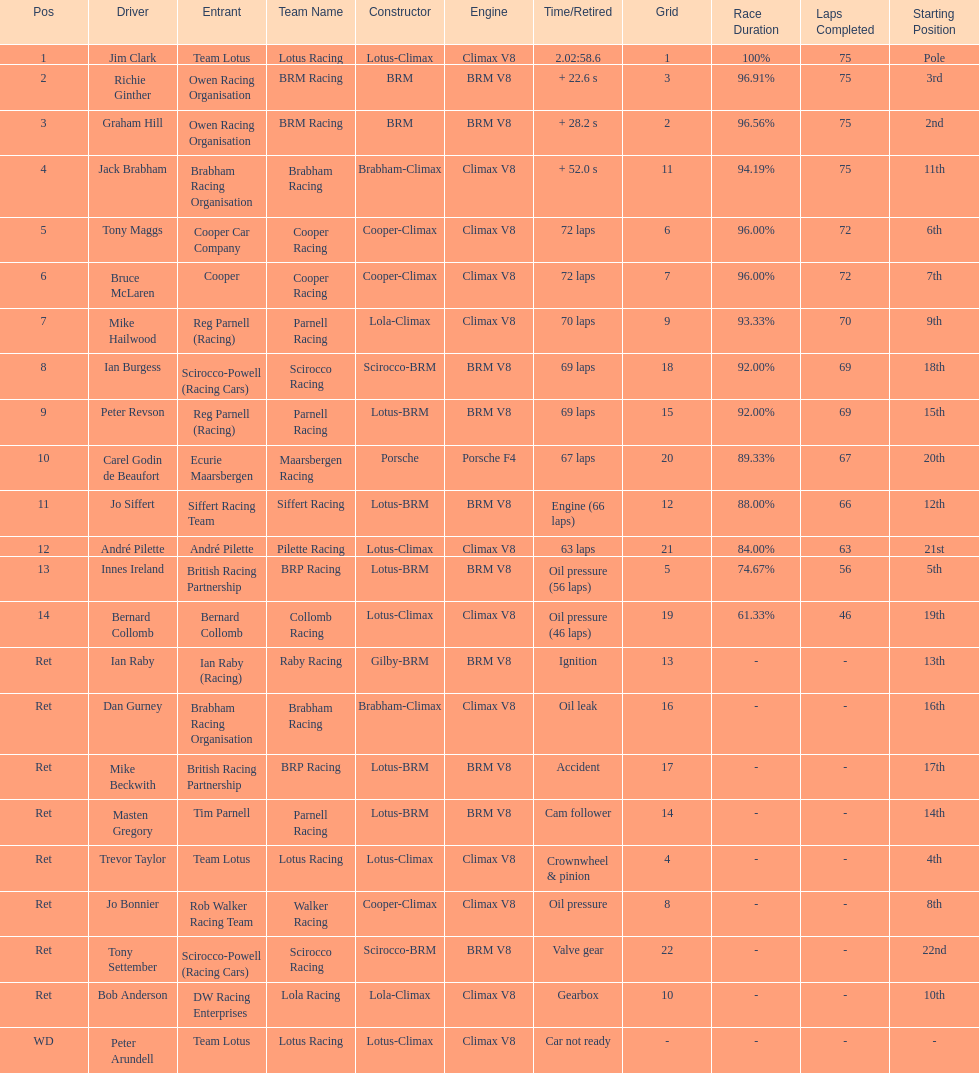Which driver did not have his/her car ready? Peter Arundell. 